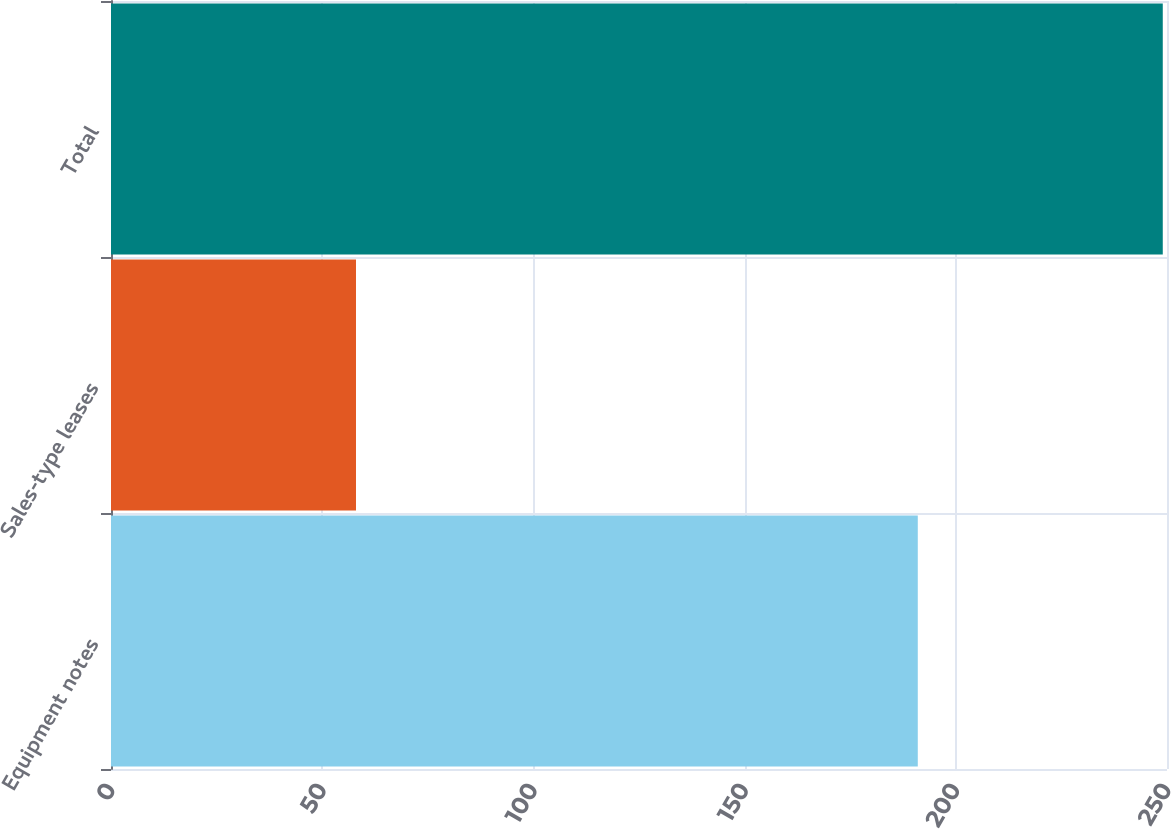Convert chart to OTSL. <chart><loc_0><loc_0><loc_500><loc_500><bar_chart><fcel>Equipment notes<fcel>Sales-type leases<fcel>Total<nl><fcel>191<fcel>58<fcel>249<nl></chart> 